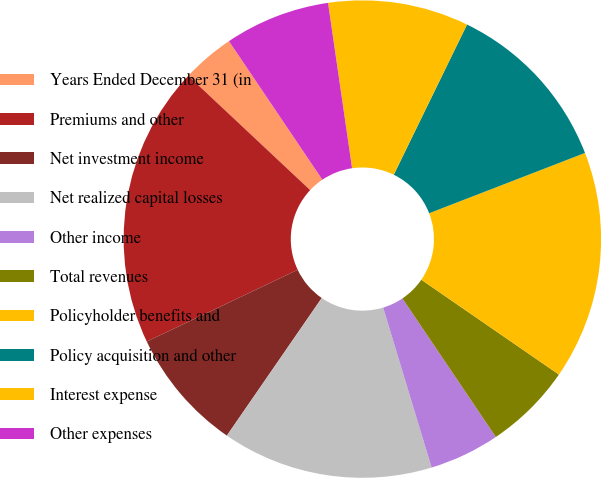Convert chart to OTSL. <chart><loc_0><loc_0><loc_500><loc_500><pie_chart><fcel>Years Ended December 31 (in<fcel>Premiums and other<fcel>Net investment income<fcel>Net realized capital losses<fcel>Other income<fcel>Total revenues<fcel>Policyholder benefits and<fcel>Policy acquisition and other<fcel>Interest expense<fcel>Other expenses<nl><fcel>3.57%<fcel>19.05%<fcel>8.33%<fcel>14.29%<fcel>4.76%<fcel>5.95%<fcel>15.48%<fcel>11.9%<fcel>9.52%<fcel>7.14%<nl></chart> 